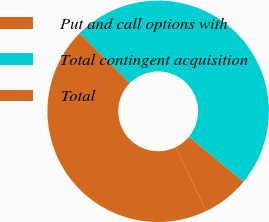Convert chart. <chart><loc_0><loc_0><loc_500><loc_500><pie_chart><fcel>Put and call options with<fcel>Total contingent acquisition<fcel>Total<nl><fcel>6.86%<fcel>48.53%<fcel>44.61%<nl></chart> 